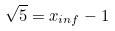Convert formula to latex. <formula><loc_0><loc_0><loc_500><loc_500>\sqrt { 5 } = x _ { i n f } - 1</formula> 